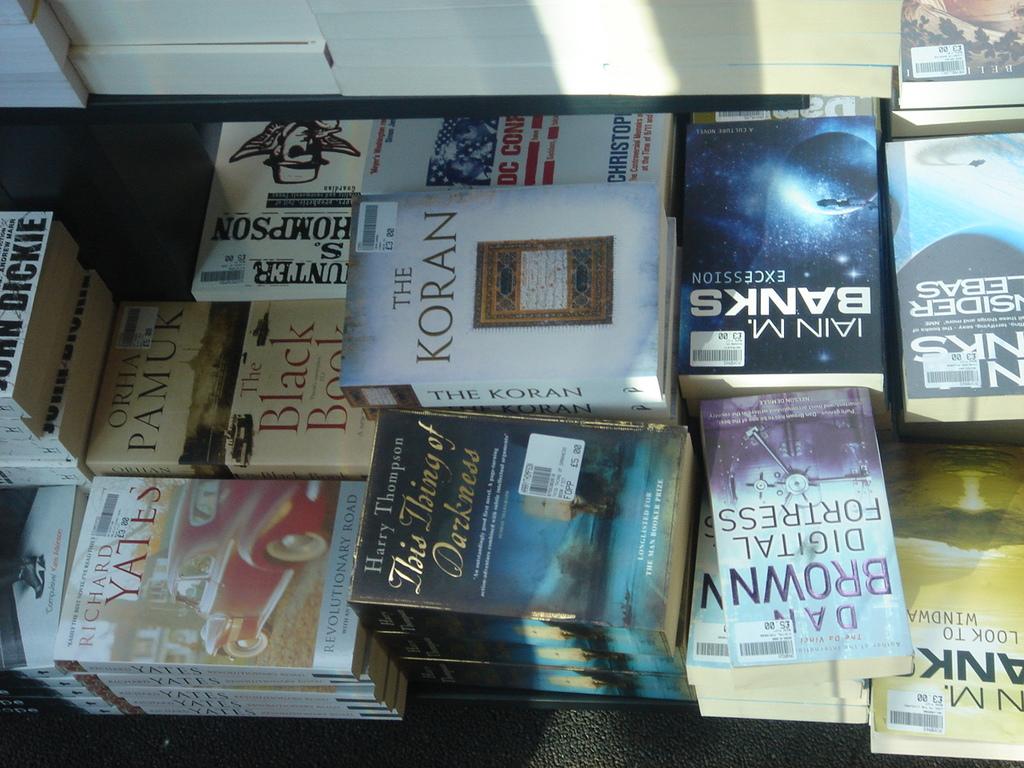Who wrote digital forensics?
Provide a short and direct response. Dan brown. What is the name of the book on the left?
Ensure brevity in your answer.  Revolutionary road. 